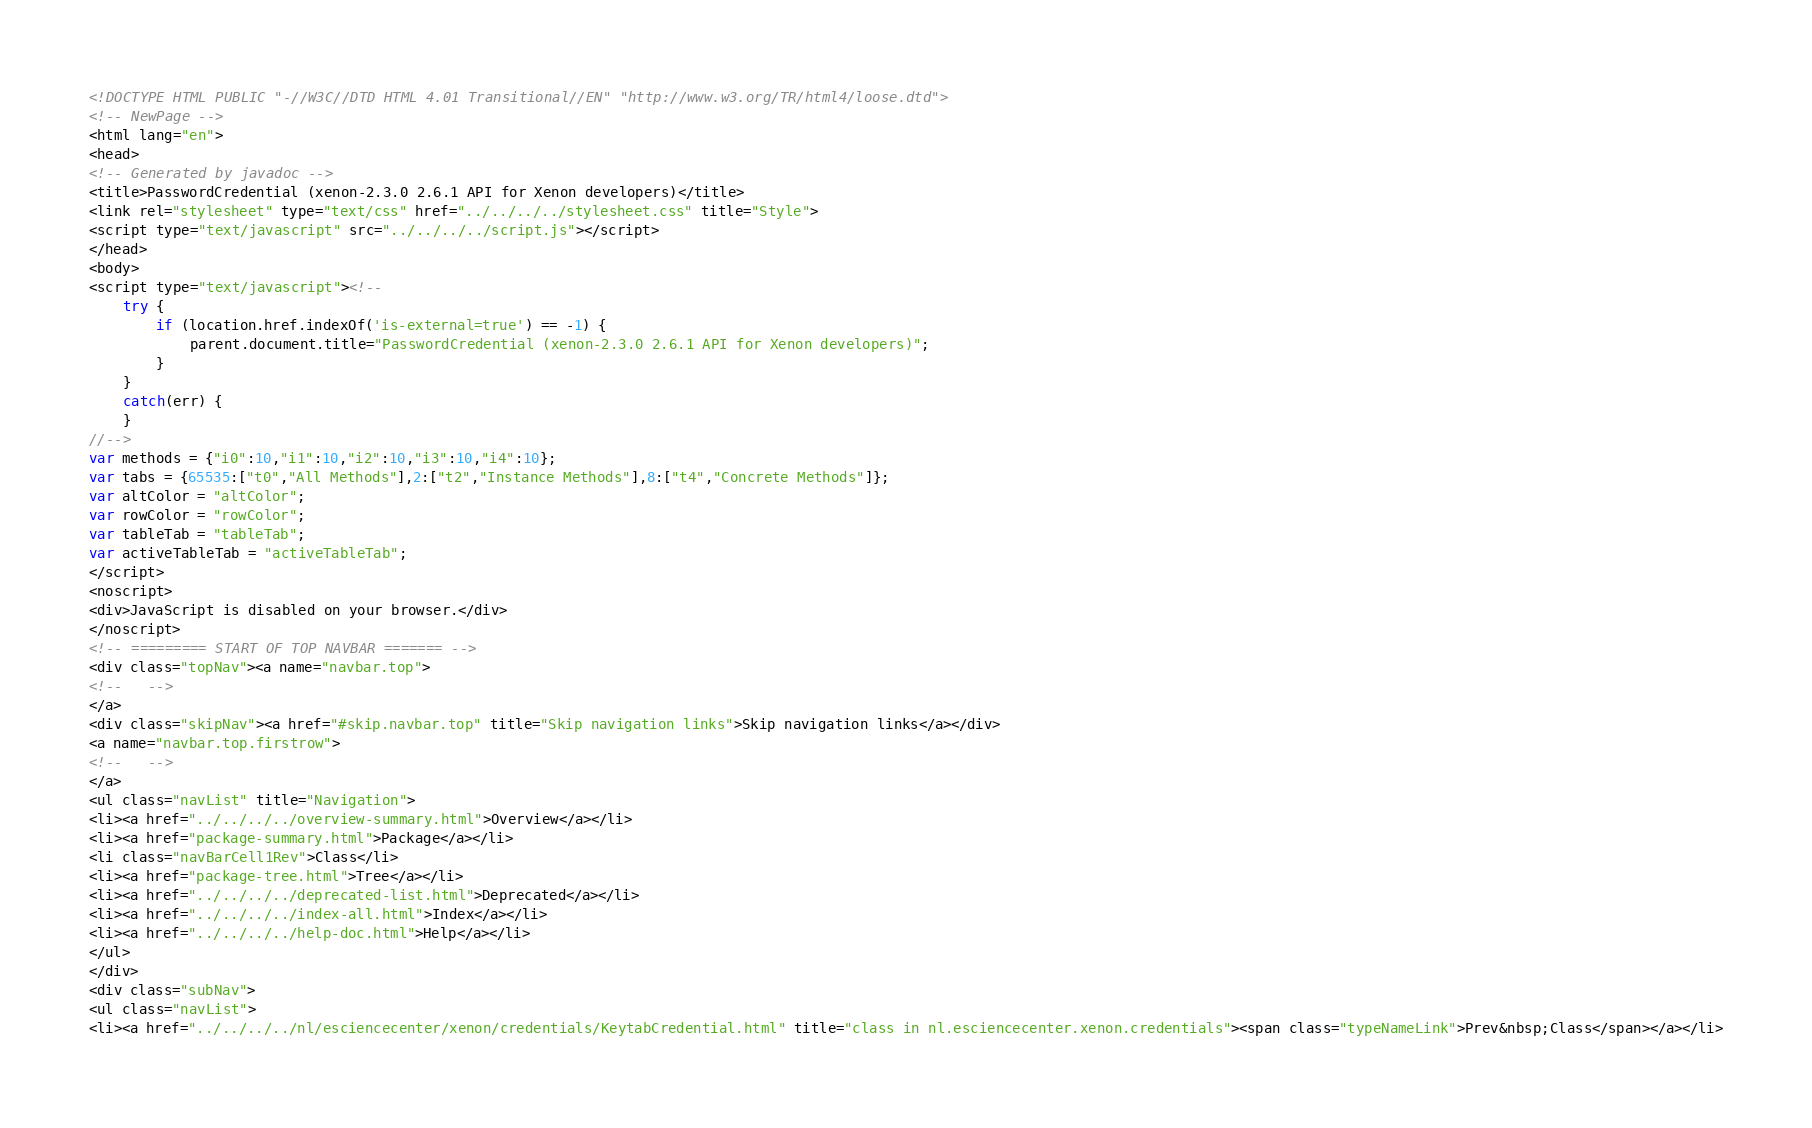Convert code to text. <code><loc_0><loc_0><loc_500><loc_500><_HTML_><!DOCTYPE HTML PUBLIC "-//W3C//DTD HTML 4.01 Transitional//EN" "http://www.w3.org/TR/html4/loose.dtd">
<!-- NewPage -->
<html lang="en">
<head>
<!-- Generated by javadoc -->
<title>PasswordCredential (xenon-2.3.0 2.6.1 API for Xenon developers)</title>
<link rel="stylesheet" type="text/css" href="../../../../stylesheet.css" title="Style">
<script type="text/javascript" src="../../../../script.js"></script>
</head>
<body>
<script type="text/javascript"><!--
    try {
        if (location.href.indexOf('is-external=true') == -1) {
            parent.document.title="PasswordCredential (xenon-2.3.0 2.6.1 API for Xenon developers)";
        }
    }
    catch(err) {
    }
//-->
var methods = {"i0":10,"i1":10,"i2":10,"i3":10,"i4":10};
var tabs = {65535:["t0","All Methods"],2:["t2","Instance Methods"],8:["t4","Concrete Methods"]};
var altColor = "altColor";
var rowColor = "rowColor";
var tableTab = "tableTab";
var activeTableTab = "activeTableTab";
</script>
<noscript>
<div>JavaScript is disabled on your browser.</div>
</noscript>
<!-- ========= START OF TOP NAVBAR ======= -->
<div class="topNav"><a name="navbar.top">
<!--   -->
</a>
<div class="skipNav"><a href="#skip.navbar.top" title="Skip navigation links">Skip navigation links</a></div>
<a name="navbar.top.firstrow">
<!--   -->
</a>
<ul class="navList" title="Navigation">
<li><a href="../../../../overview-summary.html">Overview</a></li>
<li><a href="package-summary.html">Package</a></li>
<li class="navBarCell1Rev">Class</li>
<li><a href="package-tree.html">Tree</a></li>
<li><a href="../../../../deprecated-list.html">Deprecated</a></li>
<li><a href="../../../../index-all.html">Index</a></li>
<li><a href="../../../../help-doc.html">Help</a></li>
</ul>
</div>
<div class="subNav">
<ul class="navList">
<li><a href="../../../../nl/esciencecenter/xenon/credentials/KeytabCredential.html" title="class in nl.esciencecenter.xenon.credentials"><span class="typeNameLink">Prev&nbsp;Class</span></a></li></code> 